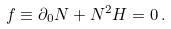Convert formula to latex. <formula><loc_0><loc_0><loc_500><loc_500>f \equiv \partial _ { 0 } N + N ^ { 2 } H = 0 { \, } .</formula> 